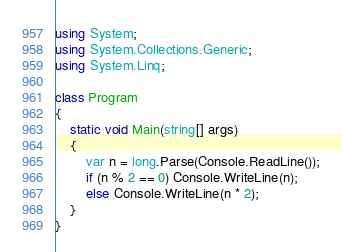Convert code to text. <code><loc_0><loc_0><loc_500><loc_500><_C#_>using System;
using System.Collections.Generic;
using System.Linq;

class Program
{
    static void Main(string[] args)
    {
        var n = long.Parse(Console.ReadLine());
        if (n % 2 == 0) Console.WriteLine(n);
        else Console.WriteLine(n * 2);
    }
}</code> 